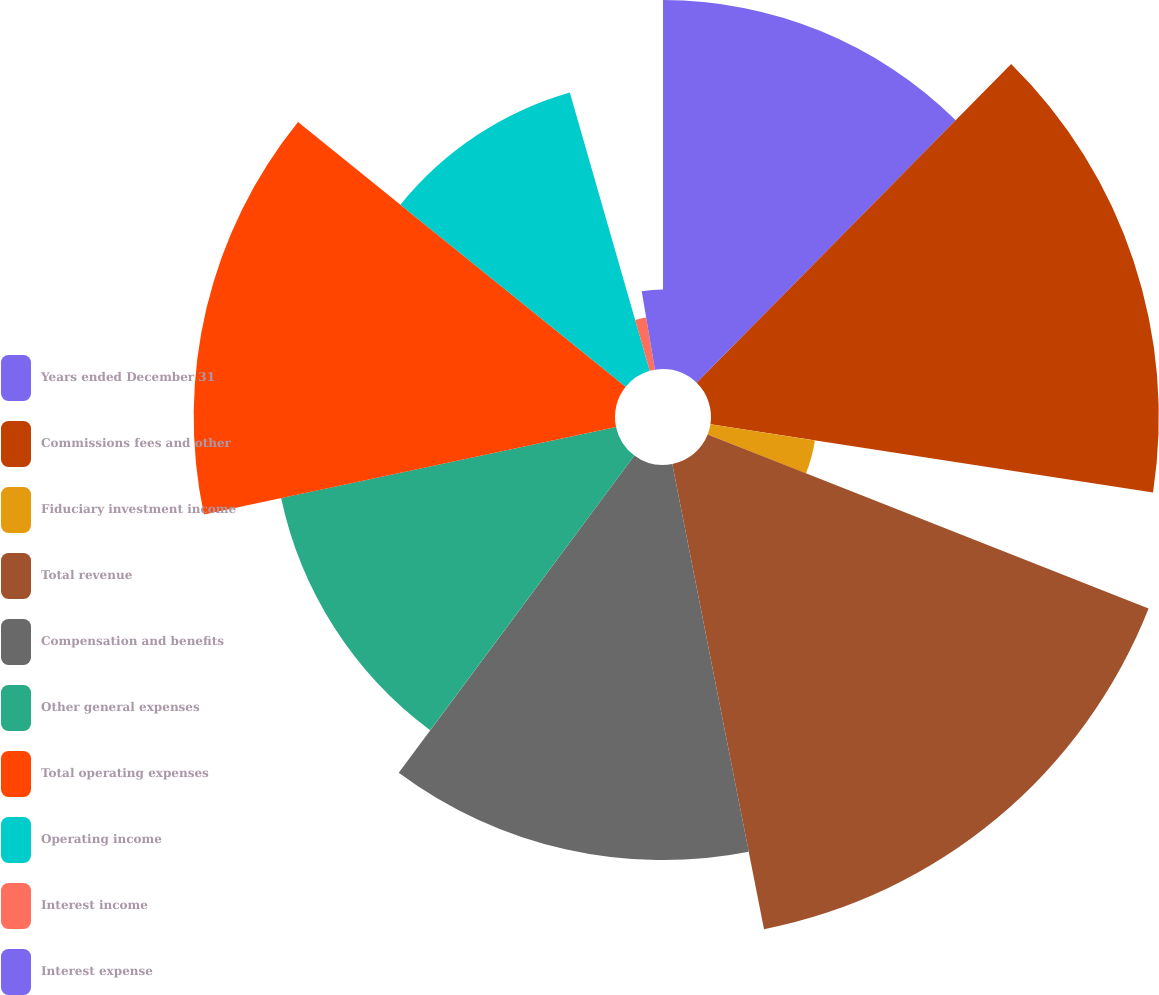Convert chart. <chart><loc_0><loc_0><loc_500><loc_500><pie_chart><fcel>Years ended December 31<fcel>Commissions fees and other<fcel>Fiduciary investment income<fcel>Total revenue<fcel>Compensation and benefits<fcel>Other general expenses<fcel>Total operating expenses<fcel>Operating income<fcel>Interest income<fcel>Interest expense<nl><fcel>12.39%<fcel>15.04%<fcel>3.55%<fcel>15.92%<fcel>13.27%<fcel>11.5%<fcel>14.15%<fcel>9.73%<fcel>1.78%<fcel>2.67%<nl></chart> 